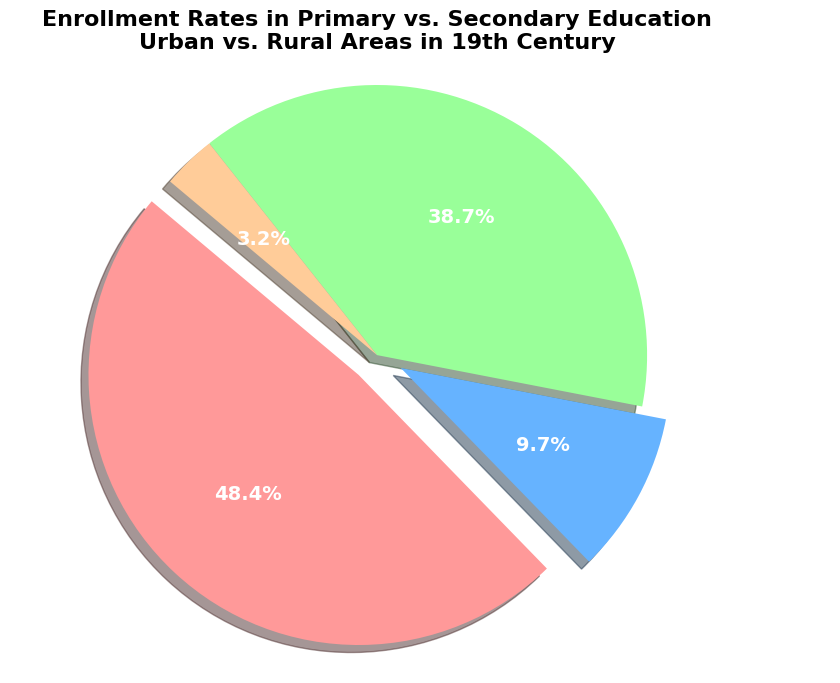Which education level has the highest enrollment rate in urban areas? From the figure, observe the size of the pie chart slices labeled 'Urban Primary' and 'Urban Secondary'. 'Urban Primary' is larger.
Answer: Urban Primary What is the total enrollment rate for primary education in both urban and rural areas combined? Add the enrollment rates of 'Urban Primary' (75%) and 'Rural Primary' (60%) from the pie chart slices. 75% + 60% = 135%.
Answer: 135% Which area has a higher secondary education enrollment rate, urban or rural? Compare the size of the pie chart slices labeled 'Urban Secondary' and 'Rural Secondary'. 'Urban Secondary' (15%) is larger than 'Rural Secondary' (5%).
Answer: Urban How much greater is the primary education enrollment rate in urban areas compared to rural areas? Subtract the enrollment rate of 'Rural Primary' (60%) from 'Urban Primary' (75%). 75% - 60% = 15%.
Answer: 15% How much lesser is the secondary enrollment rate in rural areas compared to urban areas? Subtract the enrollment rate of 'Rural Secondary' (5%) from 'Urban Secondary' (15%). 15% - 5% = 10%.
Answer: 10% What percentage of the total enrollment does rural secondary education constitute? Divide the 'Rural Secondary' enrollment rate (5%) by the total sum of all enrollment rates (75% + 15% + 60% + 5%) which is 155%, then multiply by 100. (5% / 155%) * 100 ≈ 3.23%.
Answer: 3.23% Which slice has the smallest proportion on the pie chart? Observe the relative sizes of all the slices and find the smallest one. 'Rural Secondary' is the smallest.
Answer: Rural Secondary Among the four categories, which one accounts for approximately half of the total enrollment? Identify the category whose percentage is closest to 50% of the total 155%. 'Urban Primary' contributes 75%, which is close to half of the total.
Answer: Urban Primary What is the combined enrollment rate for secondary education in both urban and rural areas? Add the enrollment rates of 'Urban Secondary' (15%) and 'Rural Secondary' (5%). 15% + 5% = 20%.
Answer: 20% Is the enrollment rate in secondary education higher in rural or primary education in rural? Compare the slices labeled 'Rural Secondary' (5%) with 'Rural Primary' (60%). 'Rural Primary' is higher.
Answer: Rural Primary 